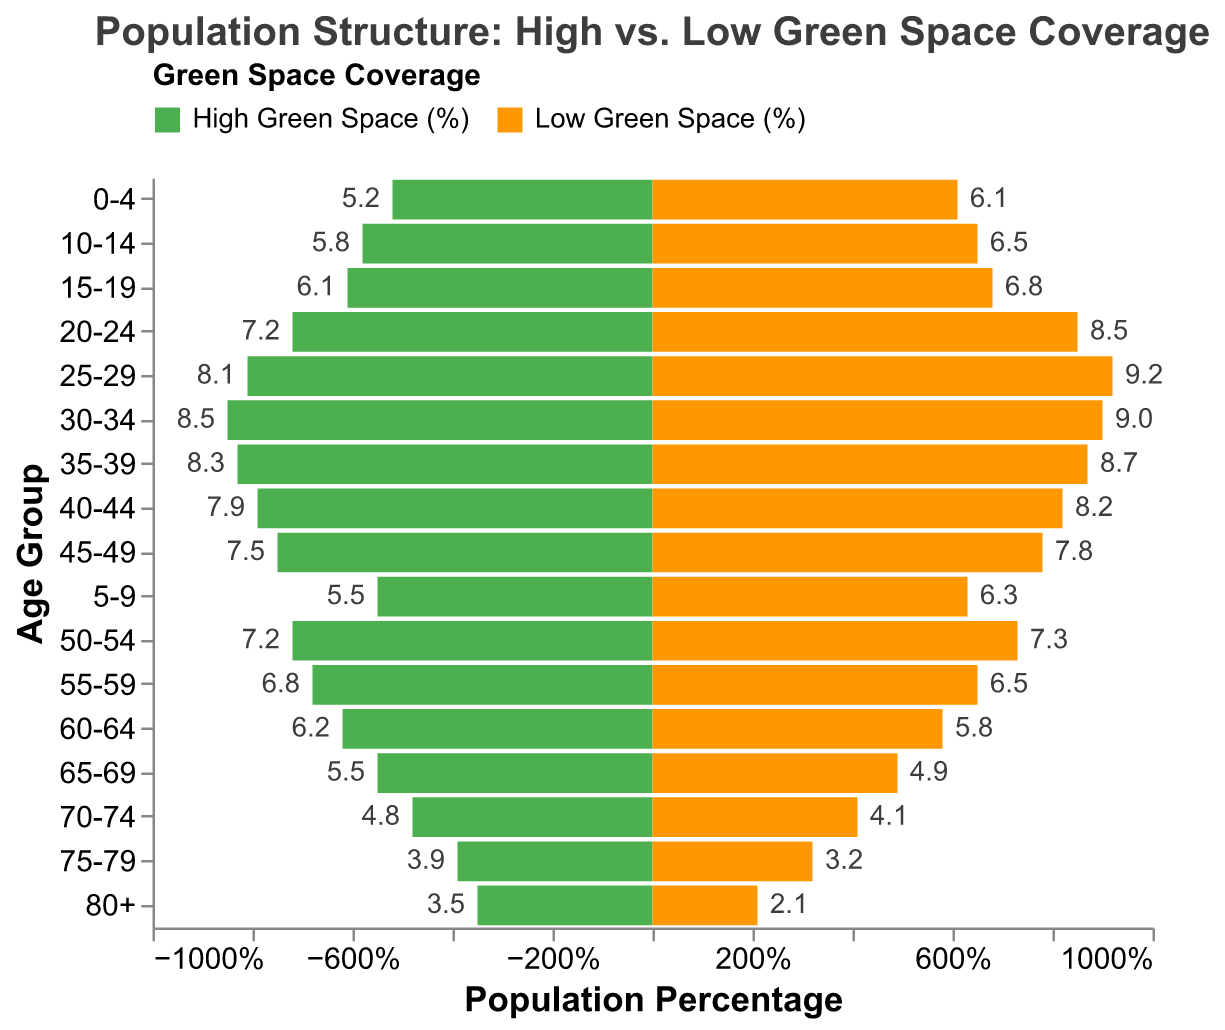What is the percentage of the population in the age group 25-29 in areas with low green space coverage? The bar corresponding to the age group 25-29 and low green space coverage shows a value of 9.2.
Answer: 9.2% Which age group has the greatest difference in population percentage between high and low green space coverage? Subtract the percentage values of both groups for each age group. The age group 80+ shows the greatest difference of 1.4% (3.5% for high green space minus 2.1% for low green space).
Answer: 80+ Are there more individuals aged 20-24 in areas with high or low green space coverage? Compare the percentages for the age group 20-24 in areas with high and low green space coverage. 8.5% for low green space is greater than 7.2% for high green space.
Answer: Low green space What is the average population percentage for age groups from 0-4 to 10-14 in high green space areas? Add the percentages (5.2 + 5.5 + 5.8) and divide by 3 to find the average (16.5/3 = 5.5).
Answer: 5.5% Which age group has a larger population percentage in high green space areas than in low green space areas? Identify the age groups where the value for high green space is greater than for low green space. For the age groups 65-69 (5.5 > 4.9), 70-74 (4.8 > 4.1), 75-79 (3.9 > 3.2), and 80+ (3.5 > 2.1), high green space percentages are larger.
Answer: 65-69, 70-74, 75-79, 80+ What is the total population percentage for age groups 60-64 and 65-69 in areas with low green space coverage? Sum the percentages of both age groups in low green space areas: 5.8% + 4.9% = 10.7%.
Answer: 10.7% Which age group has the least population percentage difference between high and low green space, and what is the value? Calculate the differences for all age groups and identify the smallest difference. For the age group 50-54, the difference is 0.1% (7.3% - 7.2%).
Answer: 50-54, 0.1% What age group between 45-49 and 55-59 has a higher percentage of people living in high green space areas? Compare the percentages for each age group: 7.5% for 45-49 and 6.8% for 55-59. The group 45-49 has a higher percentage.
Answer: 45-49 How does the population percentage of those aged 80+ compare between high and low green space areas? Compare the percentages: 3.5% for high green space and 2.1% for low green space. The percentage is higher in high green space areas.
Answer: Higher in high green space Summing population percentages from age groups 25-29 to 35-39, which area has a higher total percentage? Add up the percentages for the stated age groups: 
High green space: 8.1 + 8.5 + 8.3 = 24.9
Low green space: 9.2 + 9.0 + 8.7 = 26.9. 
The area with low green space has a higher total percentage.
Answer: Low green space 